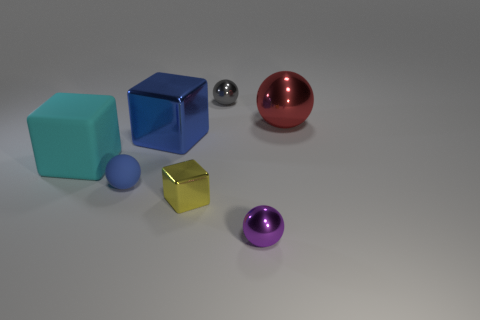Add 3 red rubber spheres. How many objects exist? 10 Subtract all blocks. How many objects are left? 4 Add 4 small blue rubber things. How many small blue rubber things are left? 5 Add 3 small gray matte blocks. How many small gray matte blocks exist? 3 Subtract 1 blue blocks. How many objects are left? 6 Subtract all tiny yellow metal things. Subtract all big red metal objects. How many objects are left? 5 